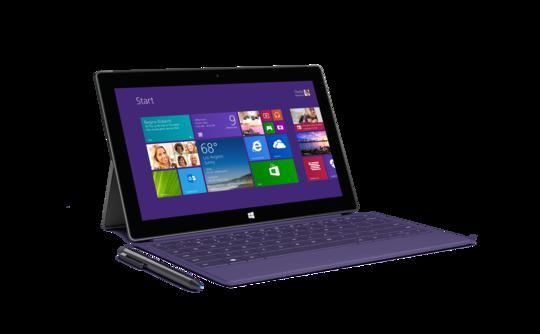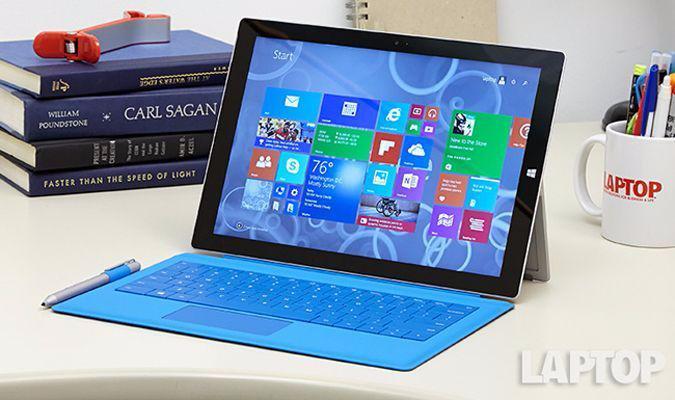The first image is the image on the left, the second image is the image on the right. For the images displayed, is the sentence "There are more than two computers in total." factually correct? Answer yes or no. No. The first image is the image on the left, the second image is the image on the right. Assess this claim about the two images: "One image shows a laptop in two views, with its screen propped like an easel, and the other image includes a screen flipped to the back of a device.". Correct or not? Answer yes or no. No. 